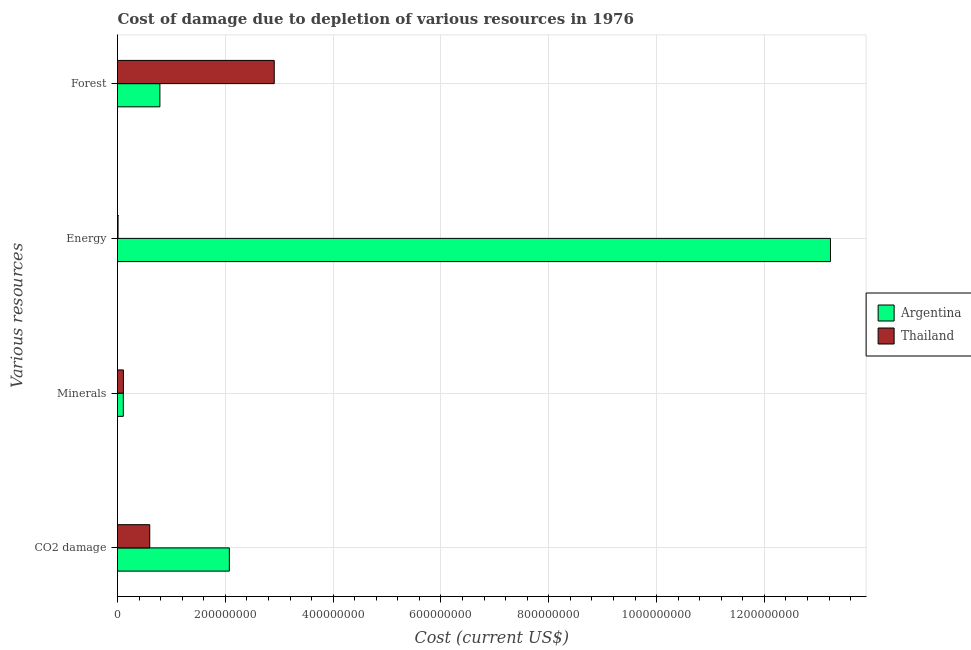How many groups of bars are there?
Offer a terse response. 4. Are the number of bars on each tick of the Y-axis equal?
Your answer should be compact. Yes. How many bars are there on the 2nd tick from the top?
Ensure brevity in your answer.  2. What is the label of the 3rd group of bars from the top?
Offer a terse response. Minerals. What is the cost of damage due to depletion of minerals in Argentina?
Give a very brief answer. 1.08e+07. Across all countries, what is the maximum cost of damage due to depletion of minerals?
Your response must be concise. 1.10e+07. Across all countries, what is the minimum cost of damage due to depletion of minerals?
Provide a short and direct response. 1.08e+07. In which country was the cost of damage due to depletion of coal minimum?
Give a very brief answer. Thailand. What is the total cost of damage due to depletion of minerals in the graph?
Keep it short and to the point. 2.17e+07. What is the difference between the cost of damage due to depletion of coal in Argentina and that in Thailand?
Your response must be concise. 1.48e+08. What is the difference between the cost of damage due to depletion of forests in Argentina and the cost of damage due to depletion of coal in Thailand?
Your answer should be compact. 1.88e+07. What is the average cost of damage due to depletion of coal per country?
Offer a terse response. 1.34e+08. What is the difference between the cost of damage due to depletion of coal and cost of damage due to depletion of minerals in Argentina?
Your answer should be compact. 1.97e+08. In how many countries, is the cost of damage due to depletion of forests greater than 1080000000 US$?
Offer a terse response. 0. What is the ratio of the cost of damage due to depletion of forests in Argentina to that in Thailand?
Provide a short and direct response. 0.27. Is the difference between the cost of damage due to depletion of energy in Argentina and Thailand greater than the difference between the cost of damage due to depletion of minerals in Argentina and Thailand?
Offer a very short reply. Yes. What is the difference between the highest and the second highest cost of damage due to depletion of forests?
Provide a succinct answer. 2.12e+08. What is the difference between the highest and the lowest cost of damage due to depletion of forests?
Offer a very short reply. 2.12e+08. In how many countries, is the cost of damage due to depletion of forests greater than the average cost of damage due to depletion of forests taken over all countries?
Offer a very short reply. 1. Is the sum of the cost of damage due to depletion of coal in Argentina and Thailand greater than the maximum cost of damage due to depletion of energy across all countries?
Make the answer very short. No. What does the 1st bar from the top in CO2 damage represents?
Offer a terse response. Thailand. What does the 1st bar from the bottom in CO2 damage represents?
Your response must be concise. Argentina. How many bars are there?
Your answer should be very brief. 8. How many countries are there in the graph?
Offer a very short reply. 2. What is the difference between two consecutive major ticks on the X-axis?
Give a very brief answer. 2.00e+08. Are the values on the major ticks of X-axis written in scientific E-notation?
Ensure brevity in your answer.  No. Does the graph contain any zero values?
Make the answer very short. No. Where does the legend appear in the graph?
Give a very brief answer. Center right. How are the legend labels stacked?
Ensure brevity in your answer.  Vertical. What is the title of the graph?
Ensure brevity in your answer.  Cost of damage due to depletion of various resources in 1976 . What is the label or title of the X-axis?
Make the answer very short. Cost (current US$). What is the label or title of the Y-axis?
Keep it short and to the point. Various resources. What is the Cost (current US$) in Argentina in CO2 damage?
Provide a succinct answer. 2.07e+08. What is the Cost (current US$) in Thailand in CO2 damage?
Ensure brevity in your answer.  5.98e+07. What is the Cost (current US$) in Argentina in Minerals?
Your answer should be compact. 1.08e+07. What is the Cost (current US$) in Thailand in Minerals?
Offer a very short reply. 1.10e+07. What is the Cost (current US$) in Argentina in Energy?
Keep it short and to the point. 1.32e+09. What is the Cost (current US$) of Thailand in Energy?
Offer a terse response. 1.04e+06. What is the Cost (current US$) in Argentina in Forest?
Your answer should be compact. 7.86e+07. What is the Cost (current US$) of Thailand in Forest?
Give a very brief answer. 2.91e+08. Across all Various resources, what is the maximum Cost (current US$) in Argentina?
Your answer should be compact. 1.32e+09. Across all Various resources, what is the maximum Cost (current US$) in Thailand?
Your answer should be compact. 2.91e+08. Across all Various resources, what is the minimum Cost (current US$) in Argentina?
Ensure brevity in your answer.  1.08e+07. Across all Various resources, what is the minimum Cost (current US$) of Thailand?
Your answer should be very brief. 1.04e+06. What is the total Cost (current US$) in Argentina in the graph?
Your answer should be very brief. 1.62e+09. What is the total Cost (current US$) in Thailand in the graph?
Your answer should be compact. 3.63e+08. What is the difference between the Cost (current US$) of Argentina in CO2 damage and that in Minerals?
Provide a short and direct response. 1.97e+08. What is the difference between the Cost (current US$) in Thailand in CO2 damage and that in Minerals?
Your answer should be compact. 4.89e+07. What is the difference between the Cost (current US$) in Argentina in CO2 damage and that in Energy?
Make the answer very short. -1.12e+09. What is the difference between the Cost (current US$) in Thailand in CO2 damage and that in Energy?
Your answer should be compact. 5.88e+07. What is the difference between the Cost (current US$) in Argentina in CO2 damage and that in Forest?
Give a very brief answer. 1.29e+08. What is the difference between the Cost (current US$) of Thailand in CO2 damage and that in Forest?
Provide a short and direct response. -2.31e+08. What is the difference between the Cost (current US$) of Argentina in Minerals and that in Energy?
Your response must be concise. -1.31e+09. What is the difference between the Cost (current US$) in Thailand in Minerals and that in Energy?
Offer a very short reply. 9.92e+06. What is the difference between the Cost (current US$) in Argentina in Minerals and that in Forest?
Provide a succinct answer. -6.79e+07. What is the difference between the Cost (current US$) in Thailand in Minerals and that in Forest?
Make the answer very short. -2.80e+08. What is the difference between the Cost (current US$) of Argentina in Energy and that in Forest?
Your answer should be very brief. 1.24e+09. What is the difference between the Cost (current US$) in Thailand in Energy and that in Forest?
Keep it short and to the point. -2.90e+08. What is the difference between the Cost (current US$) of Argentina in CO2 damage and the Cost (current US$) of Thailand in Minerals?
Keep it short and to the point. 1.96e+08. What is the difference between the Cost (current US$) of Argentina in CO2 damage and the Cost (current US$) of Thailand in Energy?
Your answer should be very brief. 2.06e+08. What is the difference between the Cost (current US$) in Argentina in CO2 damage and the Cost (current US$) in Thailand in Forest?
Your response must be concise. -8.33e+07. What is the difference between the Cost (current US$) in Argentina in Minerals and the Cost (current US$) in Thailand in Energy?
Provide a succinct answer. 9.73e+06. What is the difference between the Cost (current US$) in Argentina in Minerals and the Cost (current US$) in Thailand in Forest?
Ensure brevity in your answer.  -2.80e+08. What is the difference between the Cost (current US$) of Argentina in Energy and the Cost (current US$) of Thailand in Forest?
Make the answer very short. 1.03e+09. What is the average Cost (current US$) of Argentina per Various resources?
Offer a very short reply. 4.05e+08. What is the average Cost (current US$) of Thailand per Various resources?
Make the answer very short. 9.06e+07. What is the difference between the Cost (current US$) of Argentina and Cost (current US$) of Thailand in CO2 damage?
Provide a short and direct response. 1.48e+08. What is the difference between the Cost (current US$) of Argentina and Cost (current US$) of Thailand in Minerals?
Your response must be concise. -1.93e+05. What is the difference between the Cost (current US$) of Argentina and Cost (current US$) of Thailand in Energy?
Offer a terse response. 1.32e+09. What is the difference between the Cost (current US$) in Argentina and Cost (current US$) in Thailand in Forest?
Your answer should be very brief. -2.12e+08. What is the ratio of the Cost (current US$) of Argentina in CO2 damage to that in Minerals?
Keep it short and to the point. 19.26. What is the ratio of the Cost (current US$) of Thailand in CO2 damage to that in Minerals?
Give a very brief answer. 5.46. What is the ratio of the Cost (current US$) of Argentina in CO2 damage to that in Energy?
Offer a very short reply. 0.16. What is the ratio of the Cost (current US$) in Thailand in CO2 damage to that in Energy?
Your answer should be very brief. 57.68. What is the ratio of the Cost (current US$) of Argentina in CO2 damage to that in Forest?
Offer a very short reply. 2.64. What is the ratio of the Cost (current US$) of Thailand in CO2 damage to that in Forest?
Give a very brief answer. 0.21. What is the ratio of the Cost (current US$) of Argentina in Minerals to that in Energy?
Ensure brevity in your answer.  0.01. What is the ratio of the Cost (current US$) of Thailand in Minerals to that in Energy?
Provide a short and direct response. 10.57. What is the ratio of the Cost (current US$) of Argentina in Minerals to that in Forest?
Ensure brevity in your answer.  0.14. What is the ratio of the Cost (current US$) of Thailand in Minerals to that in Forest?
Provide a short and direct response. 0.04. What is the ratio of the Cost (current US$) in Argentina in Energy to that in Forest?
Your response must be concise. 16.82. What is the ratio of the Cost (current US$) in Thailand in Energy to that in Forest?
Ensure brevity in your answer.  0. What is the difference between the highest and the second highest Cost (current US$) of Argentina?
Keep it short and to the point. 1.12e+09. What is the difference between the highest and the second highest Cost (current US$) in Thailand?
Your response must be concise. 2.31e+08. What is the difference between the highest and the lowest Cost (current US$) in Argentina?
Offer a terse response. 1.31e+09. What is the difference between the highest and the lowest Cost (current US$) in Thailand?
Provide a short and direct response. 2.90e+08. 